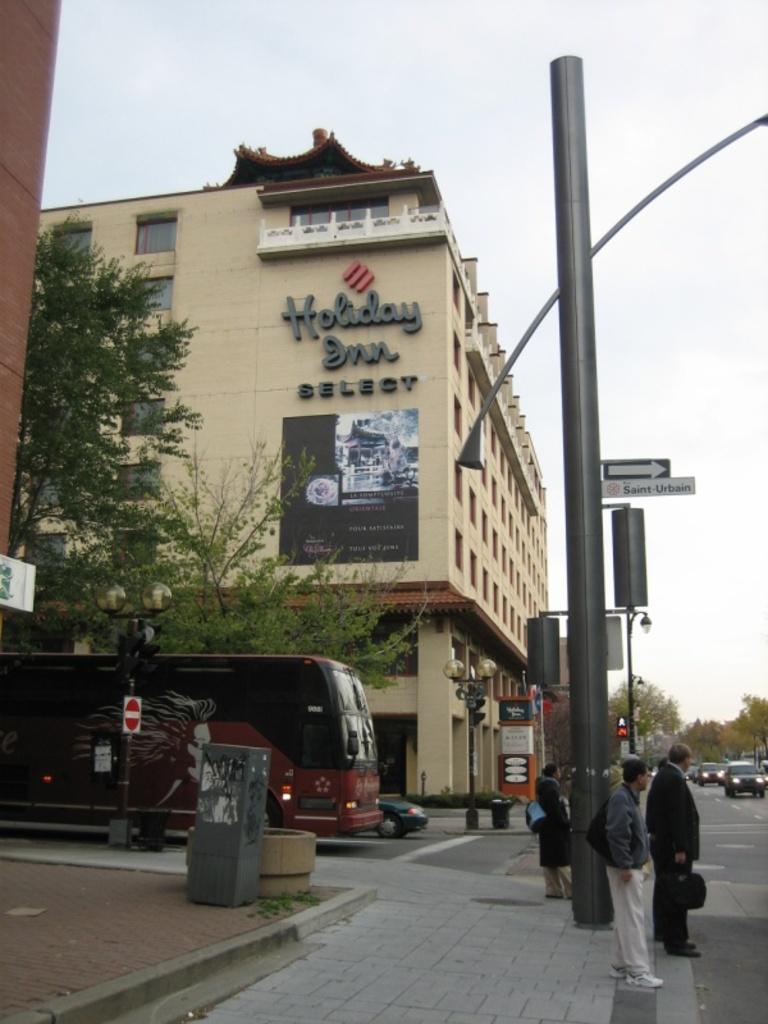Describe this image in one or two sentences. In this image I can see there is a road. On the road there are cars, Bus, Light pole, street light and a sign board. And beside the road there is a sidewalk and the person standing. And at the back there is a building and trees. And at the top there is a sky. 